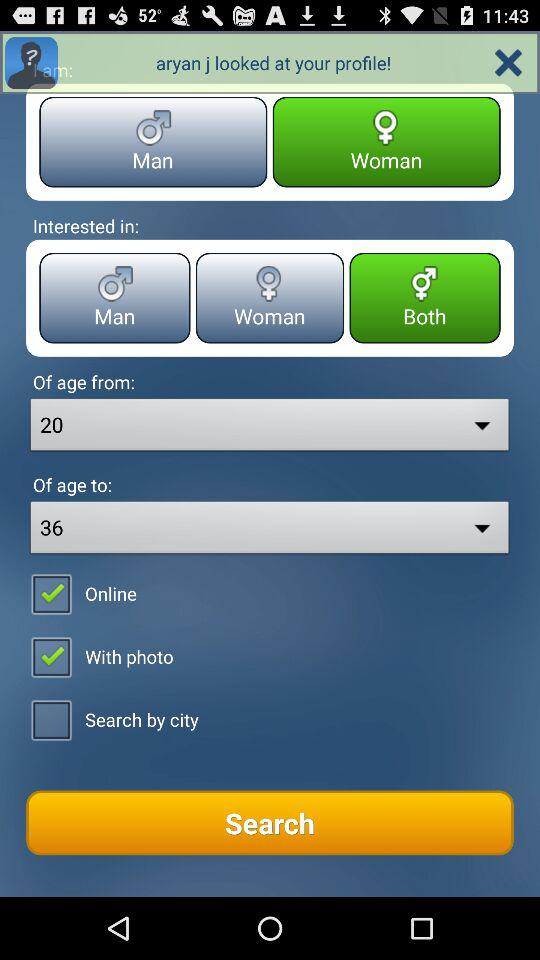Which age is selected in "from"? The selected age is 20. 